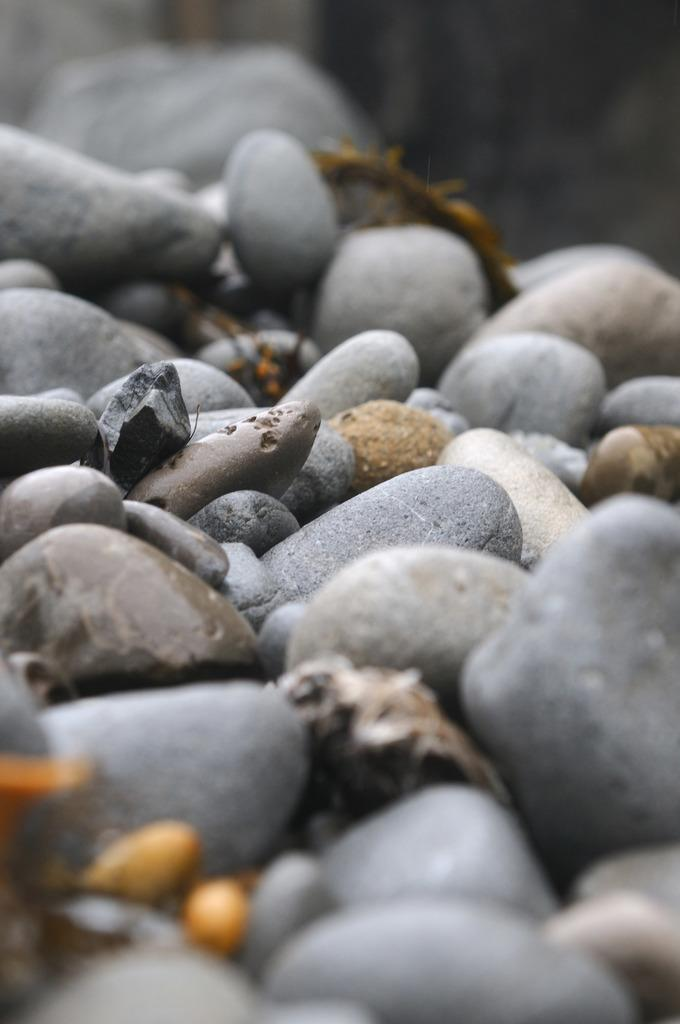What type of natural elements are present in the image? The image contains pebble stones. Can you describe the visual quality of the image? The top and bottom of the image are blurred. What type of box can be seen in the image? There is no box present in the image; it contains pebble stones. 